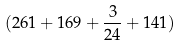<formula> <loc_0><loc_0><loc_500><loc_500>( 2 6 1 + 1 6 9 + \frac { 3 } { 2 4 } + 1 4 1 )</formula> 